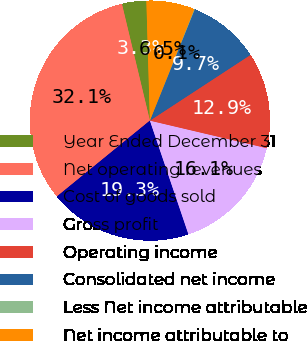Convert chart to OTSL. <chart><loc_0><loc_0><loc_500><loc_500><pie_chart><fcel>Year Ended December 31<fcel>Net operating revenues<fcel>Cost of goods sold<fcel>Gross profit<fcel>Operating income<fcel>Consolidated net income<fcel>Less Net income attributable<fcel>Net income attributable to<nl><fcel>3.28%<fcel>32.14%<fcel>19.31%<fcel>16.11%<fcel>12.9%<fcel>9.69%<fcel>0.07%<fcel>6.49%<nl></chart> 